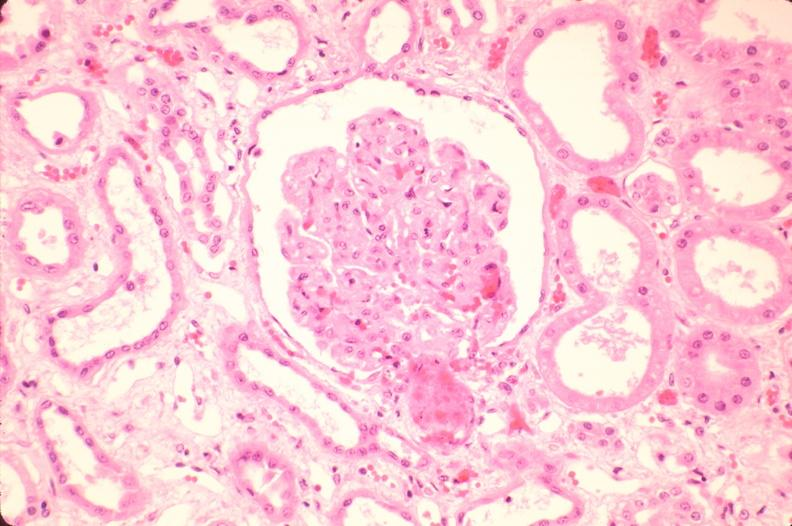where is this?
Answer the question using a single word or phrase. Urinary 